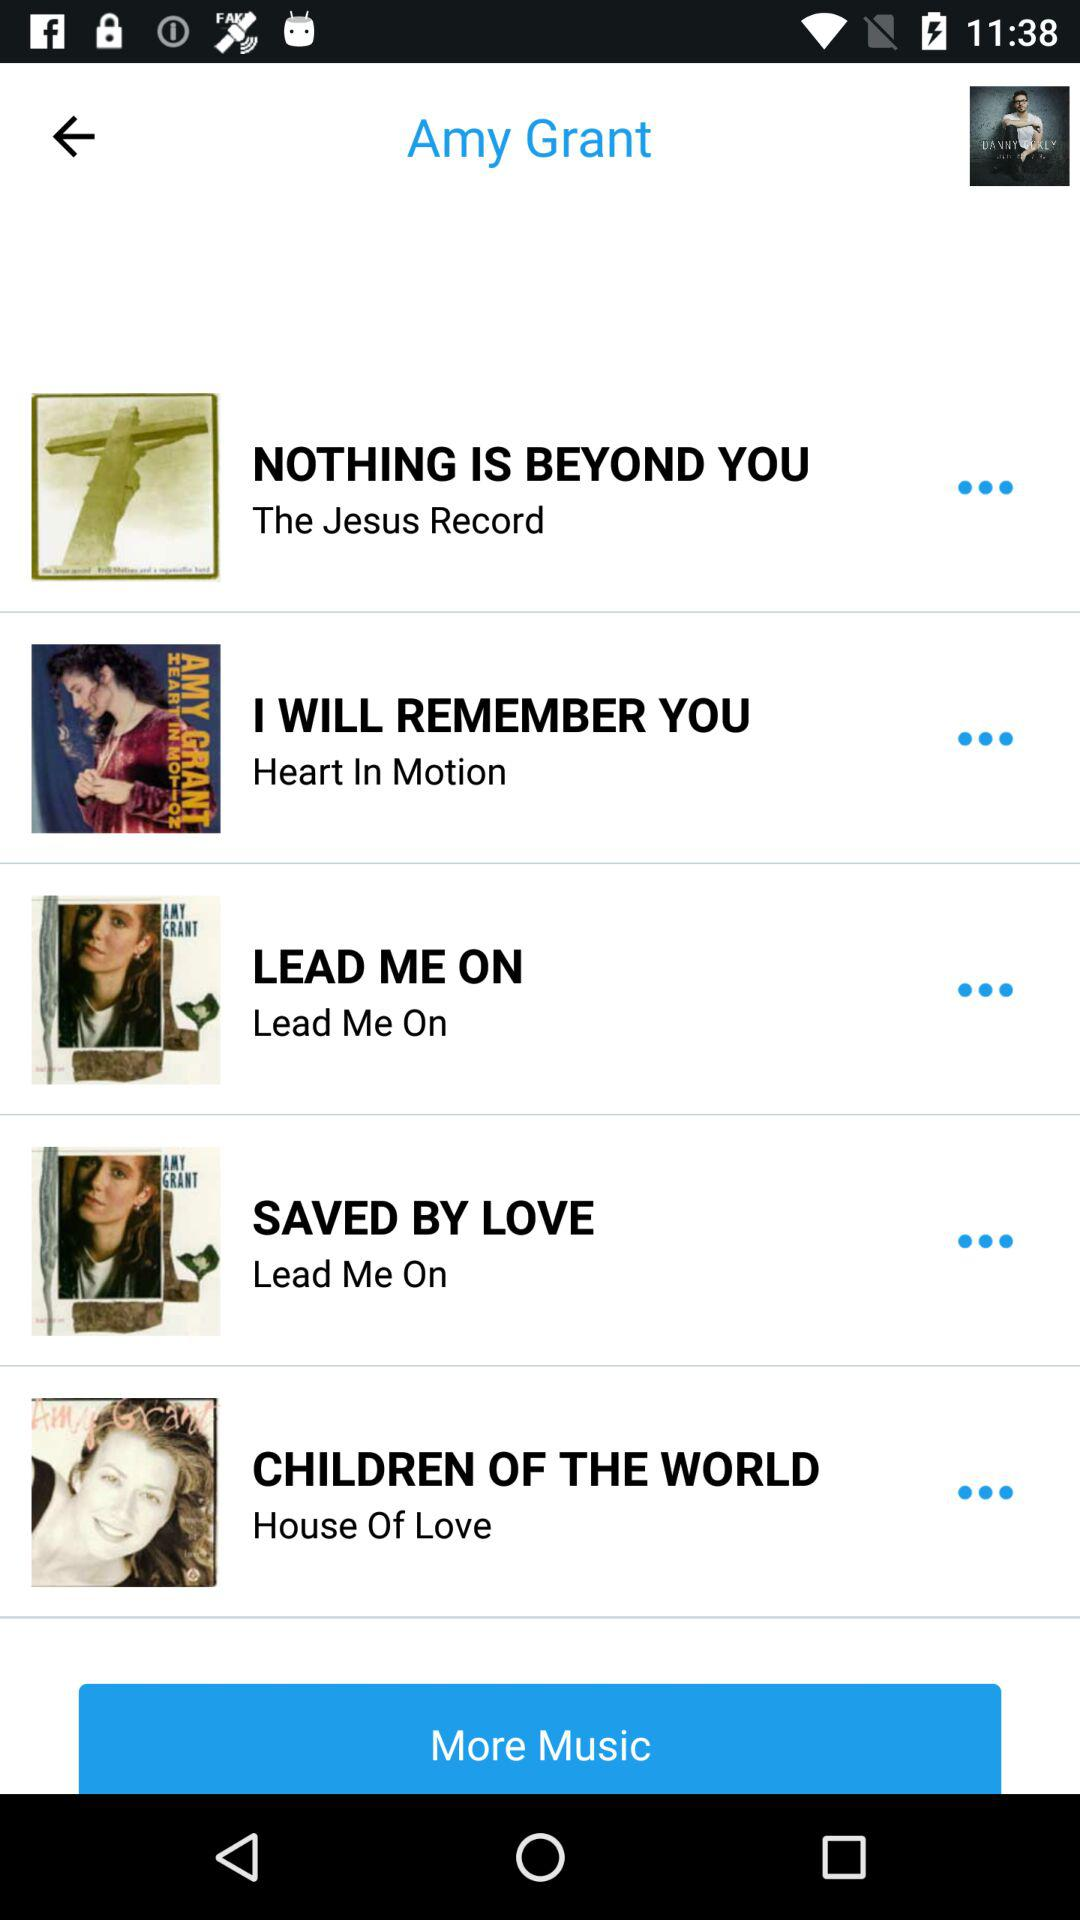"LEAD ME ON" belongs to which album? "LEAD ME ON" belongs to "Lead Me On". 